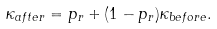<formula> <loc_0><loc_0><loc_500><loc_500>\kappa _ { a f t e r } = p _ { r } + ( 1 - p _ { r } ) \kappa _ { b e f o r e } .</formula> 